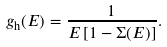Convert formula to latex. <formula><loc_0><loc_0><loc_500><loc_500>g _ { \text {h} } ( E ) = \frac { 1 } { E \left [ 1 - \Sigma ( E ) \right ] } .</formula> 